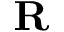Convert formula to latex. <formula><loc_0><loc_0><loc_500><loc_500>{ R }</formula> 